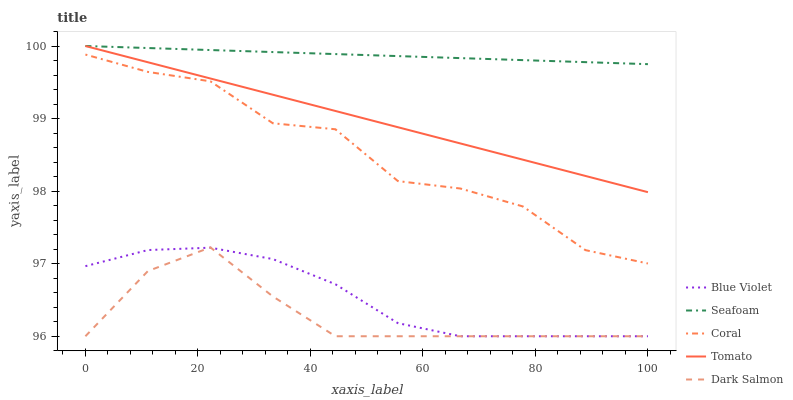Does Dark Salmon have the minimum area under the curve?
Answer yes or no. Yes. Does Seafoam have the maximum area under the curve?
Answer yes or no. Yes. Does Coral have the minimum area under the curve?
Answer yes or no. No. Does Coral have the maximum area under the curve?
Answer yes or no. No. Is Seafoam the smoothest?
Answer yes or no. Yes. Is Coral the roughest?
Answer yes or no. Yes. Is Coral the smoothest?
Answer yes or no. No. Is Seafoam the roughest?
Answer yes or no. No. Does Coral have the lowest value?
Answer yes or no. No. Does Seafoam have the highest value?
Answer yes or no. Yes. Does Coral have the highest value?
Answer yes or no. No. Is Blue Violet less than Tomato?
Answer yes or no. Yes. Is Tomato greater than Blue Violet?
Answer yes or no. Yes. Does Blue Violet intersect Dark Salmon?
Answer yes or no. Yes. Is Blue Violet less than Dark Salmon?
Answer yes or no. No. Is Blue Violet greater than Dark Salmon?
Answer yes or no. No. Does Blue Violet intersect Tomato?
Answer yes or no. No. 